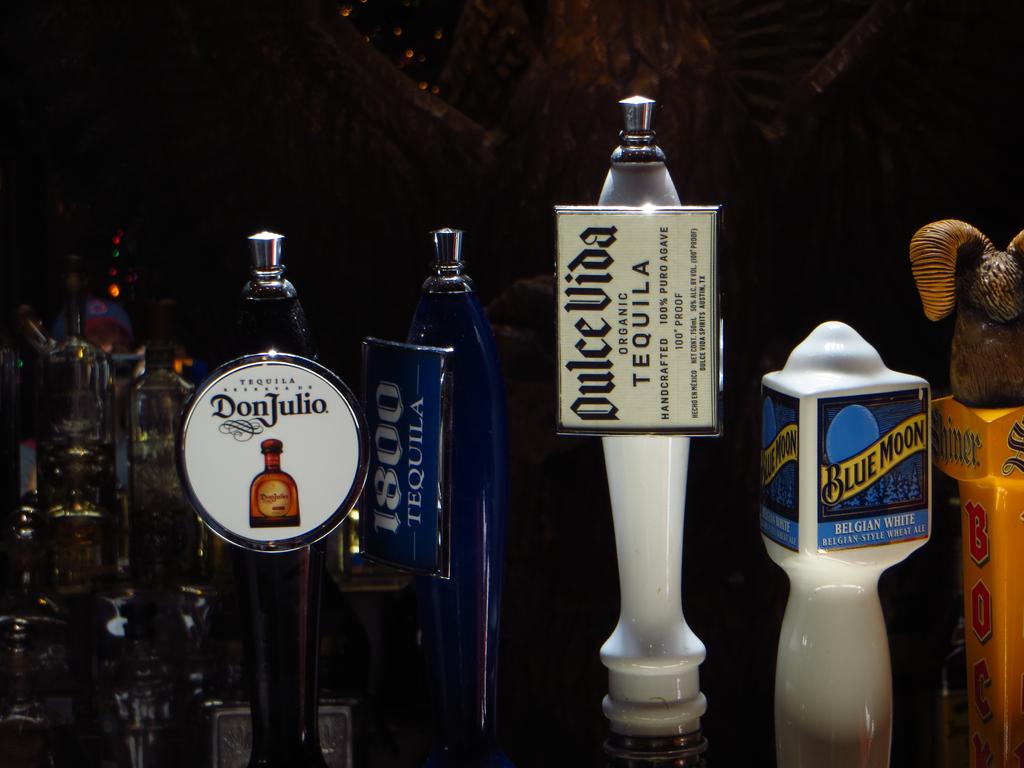What type of beer is on the yellow label on the right?
Make the answer very short. Blue moon. 